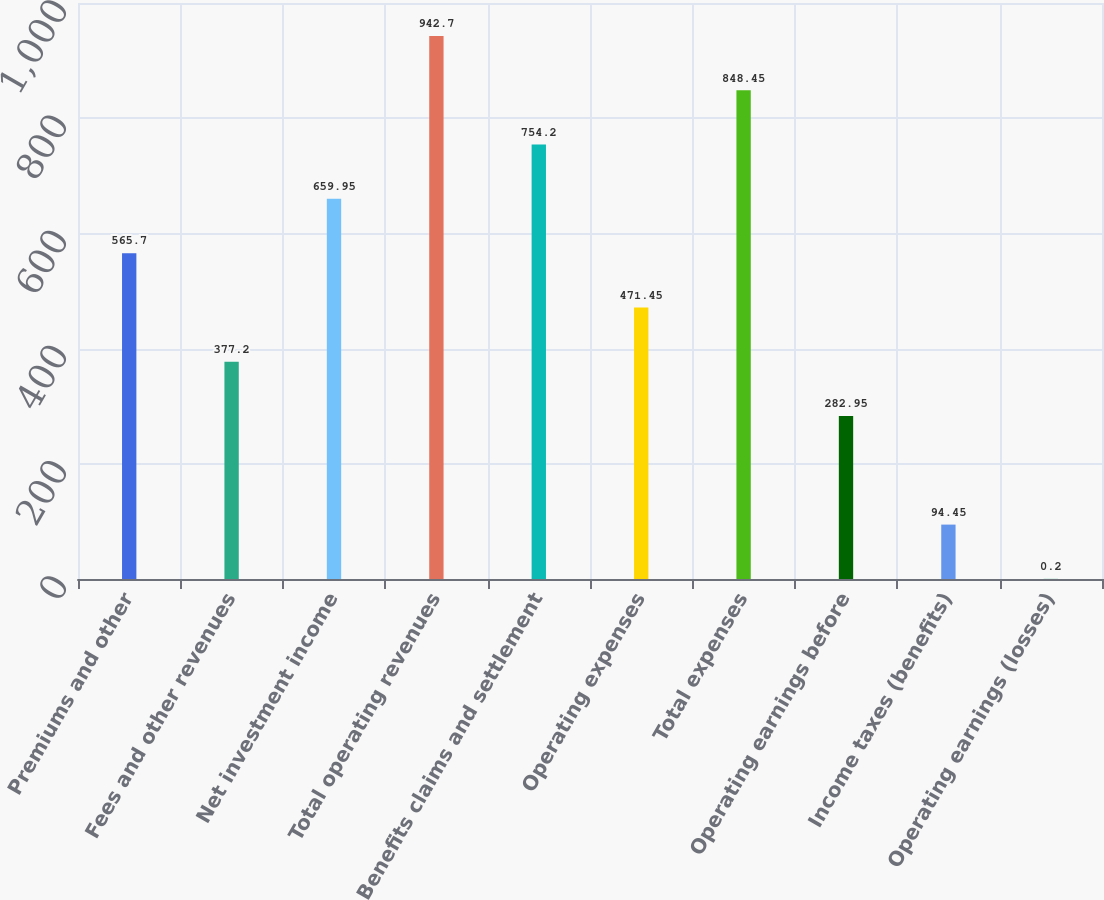<chart> <loc_0><loc_0><loc_500><loc_500><bar_chart><fcel>Premiums and other<fcel>Fees and other revenues<fcel>Net investment income<fcel>Total operating revenues<fcel>Benefits claims and settlement<fcel>Operating expenses<fcel>Total expenses<fcel>Operating earnings before<fcel>Income taxes (benefits)<fcel>Operating earnings (losses)<nl><fcel>565.7<fcel>377.2<fcel>659.95<fcel>942.7<fcel>754.2<fcel>471.45<fcel>848.45<fcel>282.95<fcel>94.45<fcel>0.2<nl></chart> 